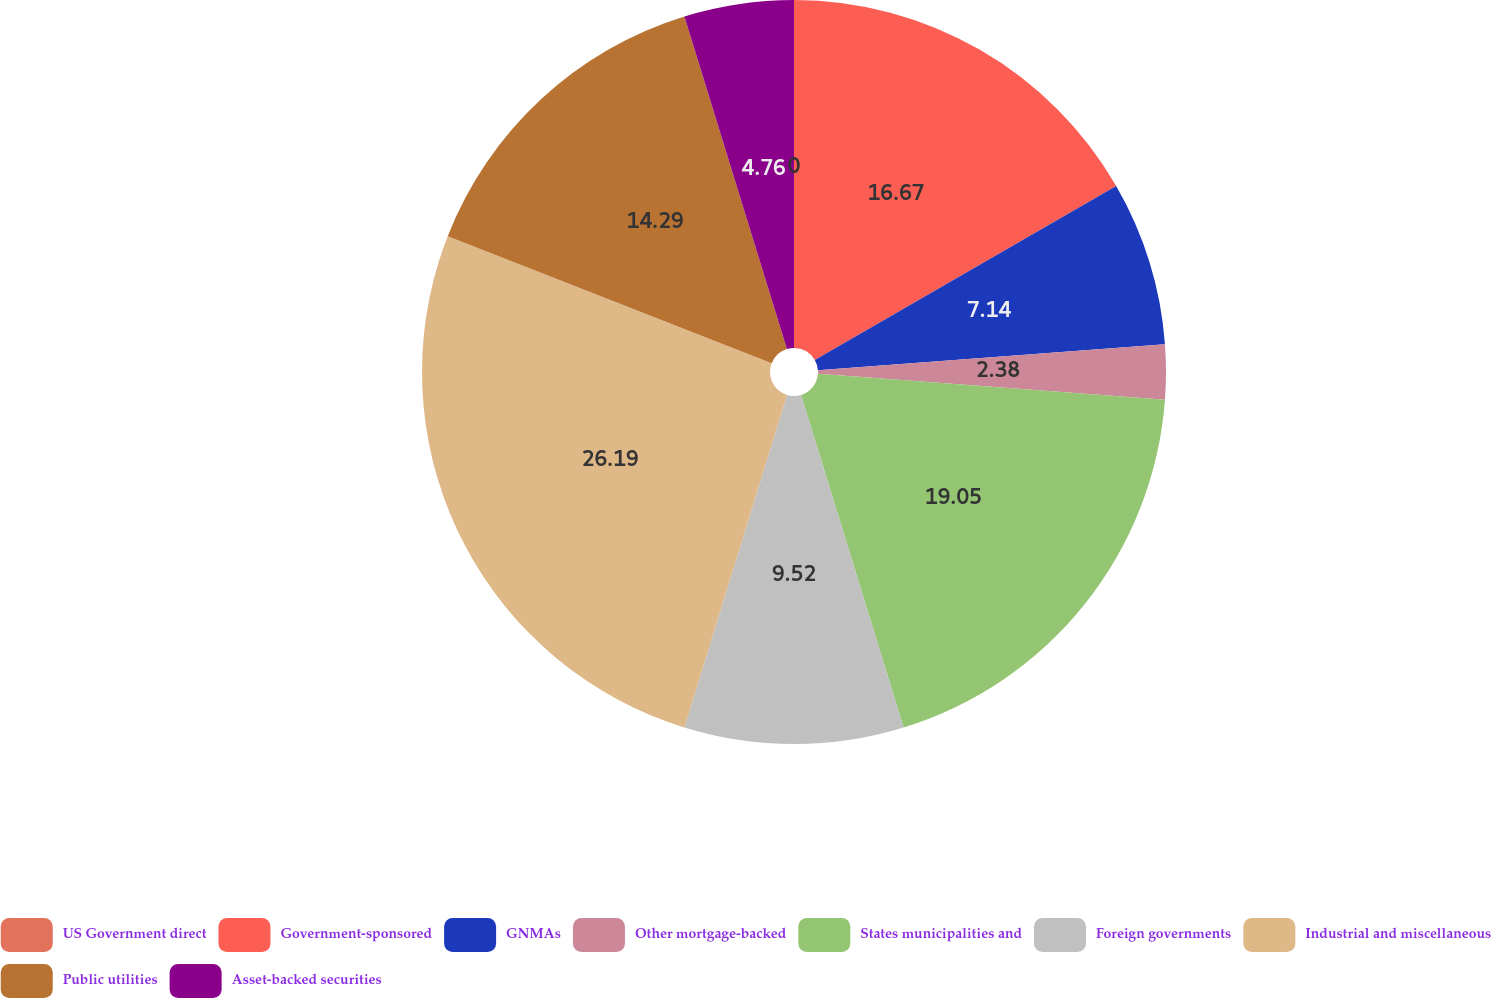<chart> <loc_0><loc_0><loc_500><loc_500><pie_chart><fcel>US Government direct<fcel>Government-sponsored<fcel>GNMAs<fcel>Other mortgage-backed<fcel>States municipalities and<fcel>Foreign governments<fcel>Industrial and miscellaneous<fcel>Public utilities<fcel>Asset-backed securities<nl><fcel>0.0%<fcel>16.67%<fcel>7.14%<fcel>2.38%<fcel>19.05%<fcel>9.52%<fcel>26.19%<fcel>14.29%<fcel>4.76%<nl></chart> 